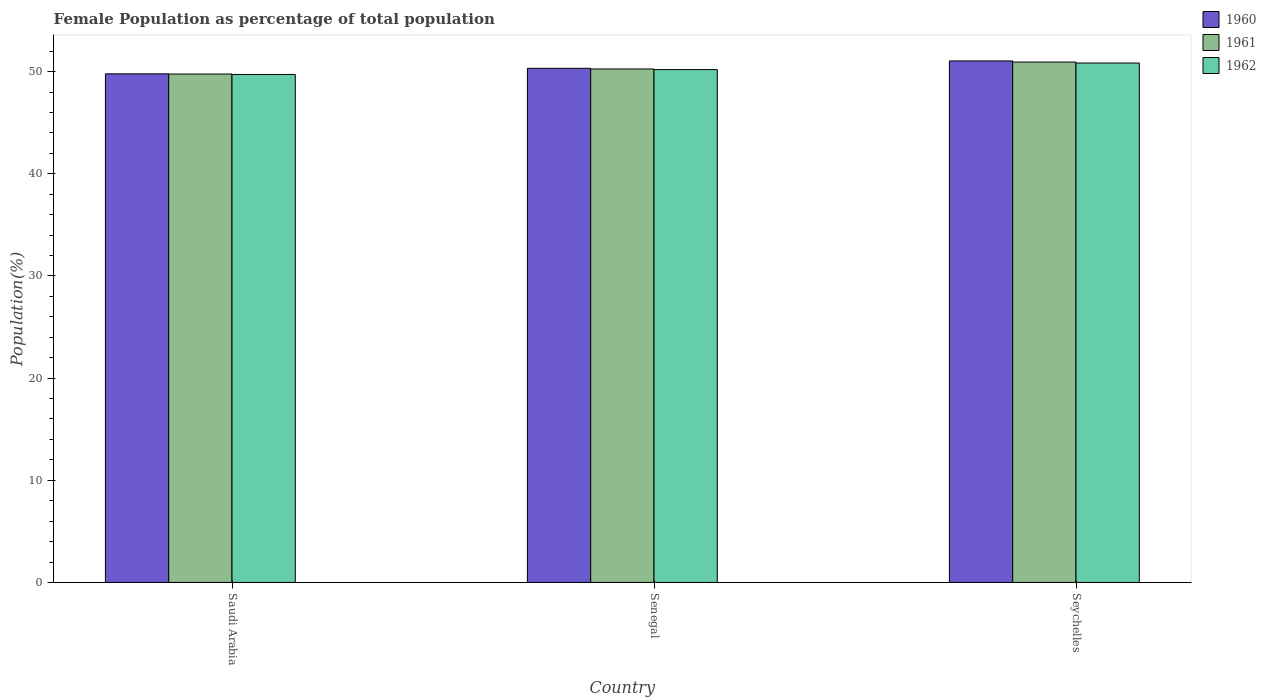How many different coloured bars are there?
Offer a terse response. 3. How many bars are there on the 3rd tick from the left?
Give a very brief answer. 3. What is the label of the 3rd group of bars from the left?
Ensure brevity in your answer.  Seychelles. In how many cases, is the number of bars for a given country not equal to the number of legend labels?
Offer a terse response. 0. What is the female population in in 1961 in Senegal?
Make the answer very short. 50.26. Across all countries, what is the maximum female population in in 1960?
Make the answer very short. 51.04. Across all countries, what is the minimum female population in in 1960?
Provide a succinct answer. 49.78. In which country was the female population in in 1962 maximum?
Provide a succinct answer. Seychelles. In which country was the female population in in 1960 minimum?
Provide a succinct answer. Saudi Arabia. What is the total female population in in 1961 in the graph?
Your response must be concise. 150.96. What is the difference between the female population in in 1961 in Senegal and that in Seychelles?
Provide a short and direct response. -0.68. What is the difference between the female population in in 1961 in Seychelles and the female population in in 1960 in Saudi Arabia?
Give a very brief answer. 1.15. What is the average female population in in 1960 per country?
Your answer should be very brief. 50.38. What is the difference between the female population in of/in 1962 and female population in of/in 1961 in Saudi Arabia?
Provide a short and direct response. -0.04. What is the ratio of the female population in in 1961 in Saudi Arabia to that in Seychelles?
Your answer should be very brief. 0.98. Is the difference between the female population in in 1962 in Saudi Arabia and Senegal greater than the difference between the female population in in 1961 in Saudi Arabia and Senegal?
Provide a succinct answer. Yes. What is the difference between the highest and the second highest female population in in 1962?
Your answer should be very brief. -1.12. What is the difference between the highest and the lowest female population in in 1962?
Offer a terse response. 1.12. In how many countries, is the female population in in 1961 greater than the average female population in in 1961 taken over all countries?
Make the answer very short. 1. How many bars are there?
Give a very brief answer. 9. Are all the bars in the graph horizontal?
Your answer should be very brief. No. How many countries are there in the graph?
Keep it short and to the point. 3. Are the values on the major ticks of Y-axis written in scientific E-notation?
Provide a succinct answer. No. Does the graph contain any zero values?
Offer a very short reply. No. Does the graph contain grids?
Offer a very short reply. No. What is the title of the graph?
Your response must be concise. Female Population as percentage of total population. What is the label or title of the X-axis?
Give a very brief answer. Country. What is the label or title of the Y-axis?
Offer a terse response. Population(%). What is the Population(%) in 1960 in Saudi Arabia?
Ensure brevity in your answer.  49.78. What is the Population(%) in 1961 in Saudi Arabia?
Your answer should be very brief. 49.76. What is the Population(%) of 1962 in Saudi Arabia?
Provide a succinct answer. 49.72. What is the Population(%) in 1960 in Senegal?
Provide a succinct answer. 50.32. What is the Population(%) of 1961 in Senegal?
Your response must be concise. 50.26. What is the Population(%) in 1962 in Senegal?
Your answer should be compact. 50.2. What is the Population(%) of 1960 in Seychelles?
Keep it short and to the point. 51.04. What is the Population(%) in 1961 in Seychelles?
Your response must be concise. 50.94. What is the Population(%) of 1962 in Seychelles?
Offer a very short reply. 50.84. Across all countries, what is the maximum Population(%) in 1960?
Ensure brevity in your answer.  51.04. Across all countries, what is the maximum Population(%) of 1961?
Keep it short and to the point. 50.94. Across all countries, what is the maximum Population(%) in 1962?
Make the answer very short. 50.84. Across all countries, what is the minimum Population(%) in 1960?
Offer a very short reply. 49.78. Across all countries, what is the minimum Population(%) in 1961?
Make the answer very short. 49.76. Across all countries, what is the minimum Population(%) of 1962?
Offer a very short reply. 49.72. What is the total Population(%) of 1960 in the graph?
Keep it short and to the point. 151.15. What is the total Population(%) in 1961 in the graph?
Offer a terse response. 150.96. What is the total Population(%) of 1962 in the graph?
Provide a succinct answer. 150.76. What is the difference between the Population(%) of 1960 in Saudi Arabia and that in Senegal?
Your response must be concise. -0.54. What is the difference between the Population(%) in 1961 in Saudi Arabia and that in Senegal?
Offer a very short reply. -0.49. What is the difference between the Population(%) of 1962 in Saudi Arabia and that in Senegal?
Provide a succinct answer. -0.48. What is the difference between the Population(%) in 1960 in Saudi Arabia and that in Seychelles?
Offer a terse response. -1.26. What is the difference between the Population(%) of 1961 in Saudi Arabia and that in Seychelles?
Make the answer very short. -1.17. What is the difference between the Population(%) in 1962 in Saudi Arabia and that in Seychelles?
Make the answer very short. -1.12. What is the difference between the Population(%) of 1960 in Senegal and that in Seychelles?
Give a very brief answer. -0.72. What is the difference between the Population(%) in 1961 in Senegal and that in Seychelles?
Your answer should be very brief. -0.68. What is the difference between the Population(%) in 1962 in Senegal and that in Seychelles?
Offer a very short reply. -0.64. What is the difference between the Population(%) of 1960 in Saudi Arabia and the Population(%) of 1961 in Senegal?
Your response must be concise. -0.47. What is the difference between the Population(%) of 1960 in Saudi Arabia and the Population(%) of 1962 in Senegal?
Offer a terse response. -0.41. What is the difference between the Population(%) of 1961 in Saudi Arabia and the Population(%) of 1962 in Senegal?
Offer a very short reply. -0.43. What is the difference between the Population(%) of 1960 in Saudi Arabia and the Population(%) of 1961 in Seychelles?
Your answer should be very brief. -1.15. What is the difference between the Population(%) in 1960 in Saudi Arabia and the Population(%) in 1962 in Seychelles?
Your response must be concise. -1.06. What is the difference between the Population(%) of 1961 in Saudi Arabia and the Population(%) of 1962 in Seychelles?
Give a very brief answer. -1.08. What is the difference between the Population(%) of 1960 in Senegal and the Population(%) of 1961 in Seychelles?
Offer a terse response. -0.61. What is the difference between the Population(%) of 1960 in Senegal and the Population(%) of 1962 in Seychelles?
Your answer should be very brief. -0.52. What is the difference between the Population(%) of 1961 in Senegal and the Population(%) of 1962 in Seychelles?
Offer a very short reply. -0.58. What is the average Population(%) of 1960 per country?
Offer a very short reply. 50.38. What is the average Population(%) in 1961 per country?
Provide a succinct answer. 50.32. What is the average Population(%) in 1962 per country?
Offer a terse response. 50.25. What is the difference between the Population(%) of 1960 and Population(%) of 1961 in Saudi Arabia?
Your answer should be very brief. 0.02. What is the difference between the Population(%) of 1960 and Population(%) of 1962 in Saudi Arabia?
Your answer should be compact. 0.06. What is the difference between the Population(%) in 1961 and Population(%) in 1962 in Saudi Arabia?
Offer a terse response. 0.04. What is the difference between the Population(%) in 1960 and Population(%) in 1961 in Senegal?
Make the answer very short. 0.07. What is the difference between the Population(%) in 1960 and Population(%) in 1962 in Senegal?
Give a very brief answer. 0.13. What is the difference between the Population(%) of 1961 and Population(%) of 1962 in Senegal?
Keep it short and to the point. 0.06. What is the difference between the Population(%) of 1960 and Population(%) of 1961 in Seychelles?
Ensure brevity in your answer.  0.11. What is the difference between the Population(%) in 1960 and Population(%) in 1962 in Seychelles?
Your answer should be compact. 0.2. What is the difference between the Population(%) in 1961 and Population(%) in 1962 in Seychelles?
Provide a short and direct response. 0.1. What is the ratio of the Population(%) of 1960 in Saudi Arabia to that in Senegal?
Your response must be concise. 0.99. What is the ratio of the Population(%) in 1961 in Saudi Arabia to that in Senegal?
Offer a terse response. 0.99. What is the ratio of the Population(%) of 1962 in Saudi Arabia to that in Senegal?
Ensure brevity in your answer.  0.99. What is the ratio of the Population(%) of 1960 in Saudi Arabia to that in Seychelles?
Ensure brevity in your answer.  0.98. What is the ratio of the Population(%) in 1962 in Saudi Arabia to that in Seychelles?
Provide a succinct answer. 0.98. What is the ratio of the Population(%) in 1960 in Senegal to that in Seychelles?
Offer a terse response. 0.99. What is the ratio of the Population(%) in 1961 in Senegal to that in Seychelles?
Offer a very short reply. 0.99. What is the ratio of the Population(%) in 1962 in Senegal to that in Seychelles?
Your answer should be very brief. 0.99. What is the difference between the highest and the second highest Population(%) of 1960?
Offer a very short reply. 0.72. What is the difference between the highest and the second highest Population(%) of 1961?
Your answer should be very brief. 0.68. What is the difference between the highest and the second highest Population(%) of 1962?
Give a very brief answer. 0.64. What is the difference between the highest and the lowest Population(%) in 1960?
Make the answer very short. 1.26. What is the difference between the highest and the lowest Population(%) in 1961?
Provide a short and direct response. 1.17. What is the difference between the highest and the lowest Population(%) of 1962?
Ensure brevity in your answer.  1.12. 